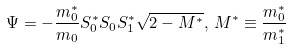Convert formula to latex. <formula><loc_0><loc_0><loc_500><loc_500>\Psi = - \frac { m _ { 0 } ^ { * } } { m _ { 0 } } S _ { 0 } ^ { * } S _ { 0 } S _ { 1 } ^ { * } \sqrt { 2 - M ^ { * } } , \, M ^ { * } \equiv \frac { m _ { 0 } ^ { * } } { m _ { 1 } ^ { * } }</formula> 